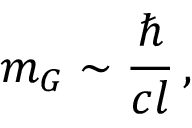<formula> <loc_0><loc_0><loc_500><loc_500>m _ { G } \sim \frac { } { c l } \, ,</formula> 